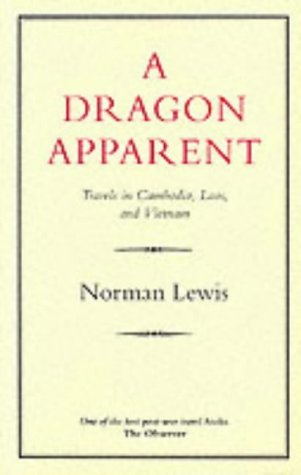What type of book is this? This book is a travel narrative, exploring the vivid landscapes and rich cultural tapestry of Southeast Asia through the eyes of Norman Lewis. 